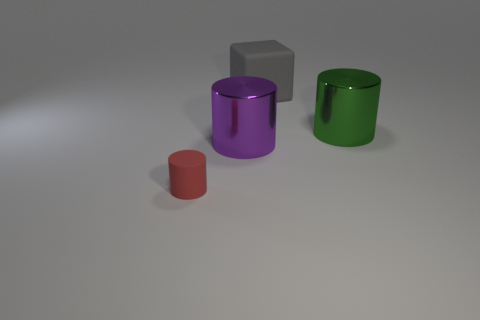Subtract all large cylinders. How many cylinders are left? 1 Subtract 1 cylinders. How many cylinders are left? 2 Add 4 brown rubber objects. How many objects exist? 8 Subtract all cylinders. How many objects are left? 1 Subtract all gray matte things. Subtract all purple shiny cylinders. How many objects are left? 2 Add 1 big gray blocks. How many big gray blocks are left? 2 Add 4 large yellow metallic cubes. How many large yellow metallic cubes exist? 4 Subtract 0 yellow spheres. How many objects are left? 4 